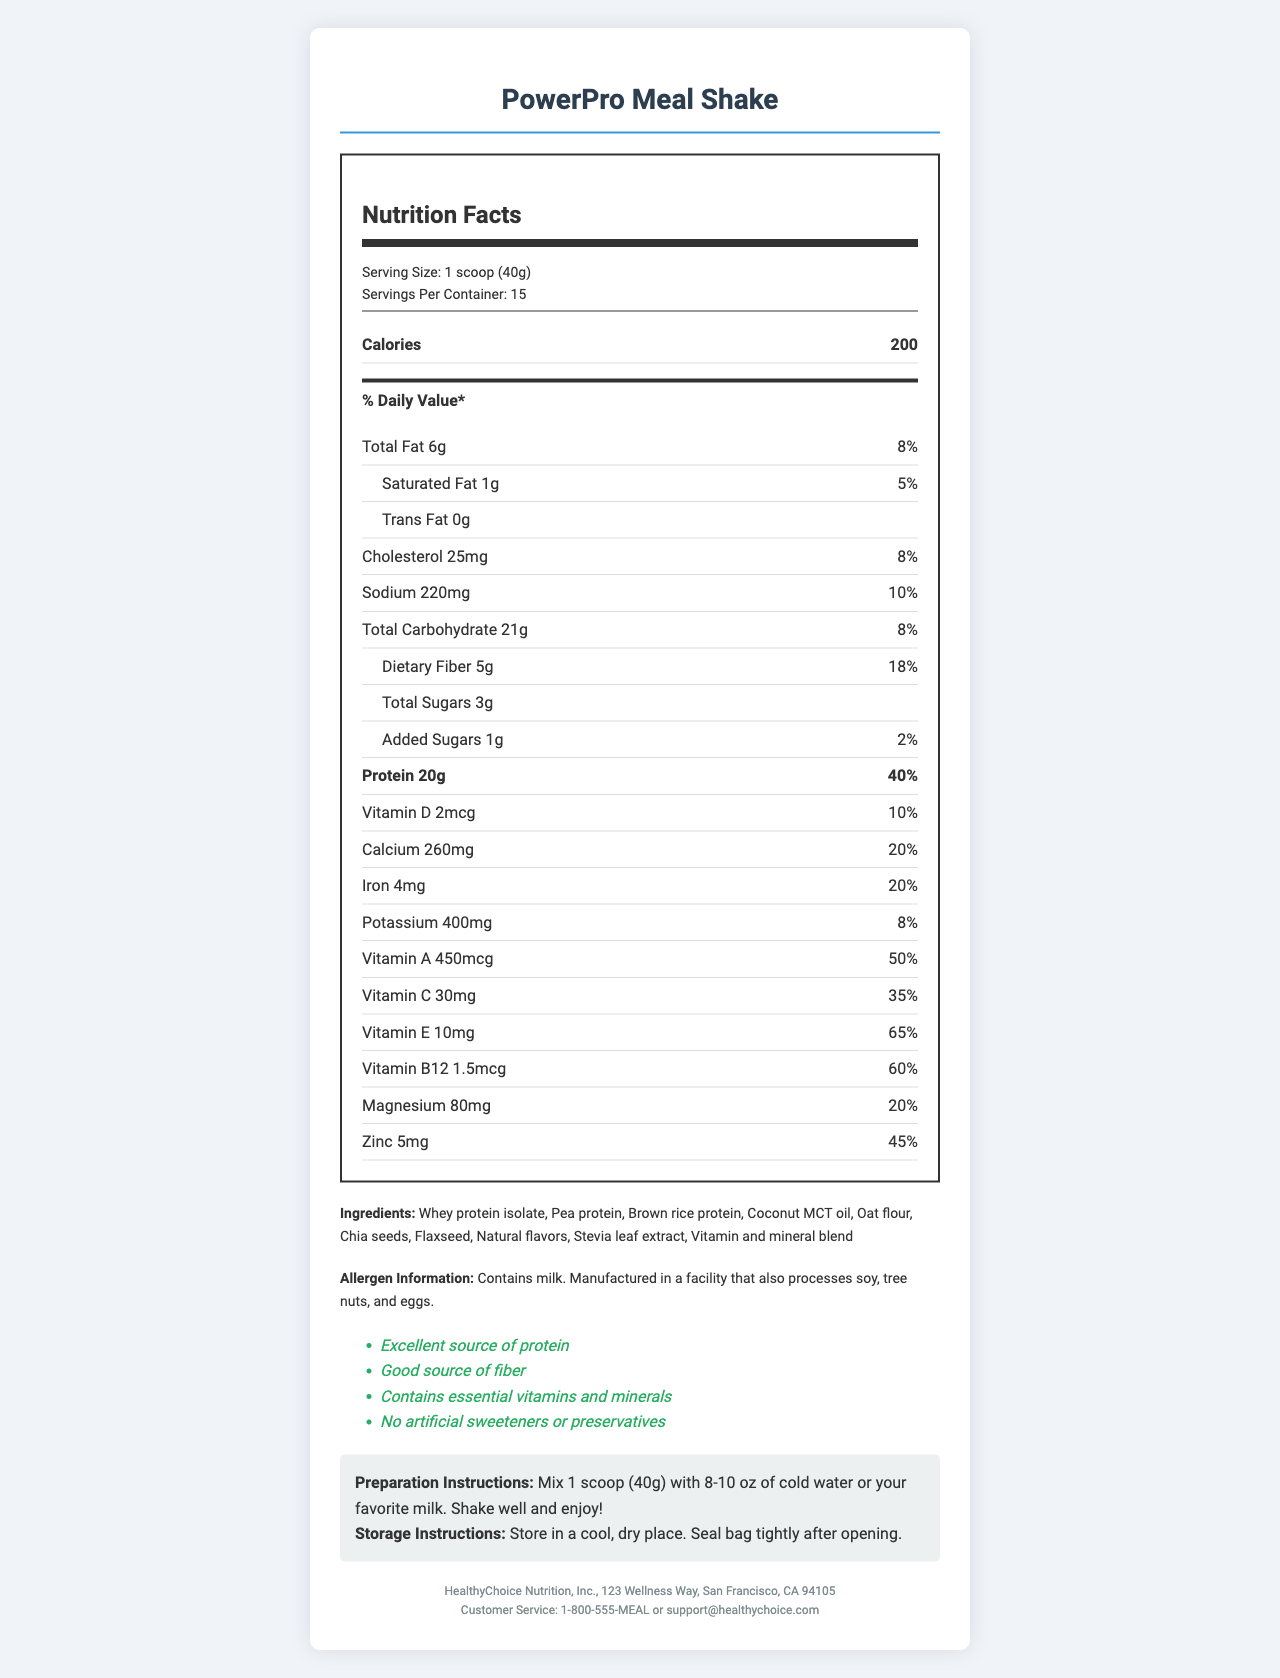what is the product name? The product name is indicated at the top of the document in the title.
Answer: PowerPro Meal Shake what is the serving size of the PowerPro Meal Shake? The serving size is clearly specified in the "Nutrition Facts" section under "Serving Size."
Answer: 1 scoop (40g) how many servings per container are there? The number of servings per container is mentioned right below the serving size.
Answer: 15 what is the total amount of protein per serving? The amount of protein per serving is listed in the "Nutrition Facts" section and highlighted in bold.
Answer: 20g what are the main ingredients in the PowerPro Meal Shake? The main ingredients are listed under the "Ingredients" section in the document.
Answer: Whey protein isolate, Pea protein, Brown rice protein, Coconut MCT oil, Oat flour, Chia seeds, Flaxseed, Natural flavors, Stevia leaf extract, Vitamin and mineral blend how many calories are in one serving of the meal shake? The number of calories per serving is displayed prominently in the "Nutrition Facts" section.
Answer: 200 what is the daily value percentage of dietary fiber in one serving? The daily value percentage for dietary fiber can be found in the "Nutrition Facts" section under "Dietary Fiber."
Answer: 18% how much sodium is in one serving, and what is its percentage of the daily value? The amount of sodium and its daily value percentage are provided in the "Nutrition Facts" section under "Sodium."
Answer: 220mg, 10% what are the health claims made about the PowerPro Meal Shake? The health claims are listed under the "Health Claims" section in the document.
Answer: Excellent source of protein, Good source of fiber, Contains essential vitamins and minerals, No artificial sweeteners or preservatives what allergens does the product contain? The allergen information is provided under the "Allergen Information" section.
Answer: Contains milk. Manufactured in a facility that also processes soy, tree nuts, and eggs. which of the following is NOT an ingredient in the PowerPro Meal Shake? A. Chia seeds B. Vitamin and mineral blend C. Artificial sweeteners D. Flaxseed Artificial sweeteners are listed under health claims as "No artificial sweeteners or preservatives" and thus not an ingredient.
Answer: C. Artificial sweeteners which vitamin is present in the highest percentage of daily value per serving? A. Vitamin D B. Vitamin C C. Vitamin E D. Vitamin B12 The "Nutrition Facts" indicate Vitamin E has a daily value of 65%, which is the highest among all listed vitamins.
Answer: C. Vitamin E is the PowerPro Meal Shake suitable for someone avoiding dairy? The allergen information specifies that the product contains milk.
Answer: No summarize the main features and nutritional benefits of the PowerPro Meal Shake. The document outlines the nutritional value, ingredients, health benefits, and allergen information of the PowerPro Meal Shake. It highlights the high protein content and the presence of essential vitamins and minerals while emphasizing no artificial sweeteners or preservatives.
Answer: The PowerPro Meal Shake is a high-protein meal replacement designed for busy professionals. It provides 200 calories per serving with essential nutrients such as protein, fiber, vitamins, and minerals. The product contains ingredients like whey protein isolate, pea protein, and chia seeds. Health claims include being an excellent source of protein and fiber with no artificial ingredients. It contains allergens like milk and is manufactured in a facility processing other allergens. what is the cost per serving of the PowerPro Meal Shake? The document does not provide any information regarding the pricing or cost per serving of the product.
Answer: Cannot be determined 